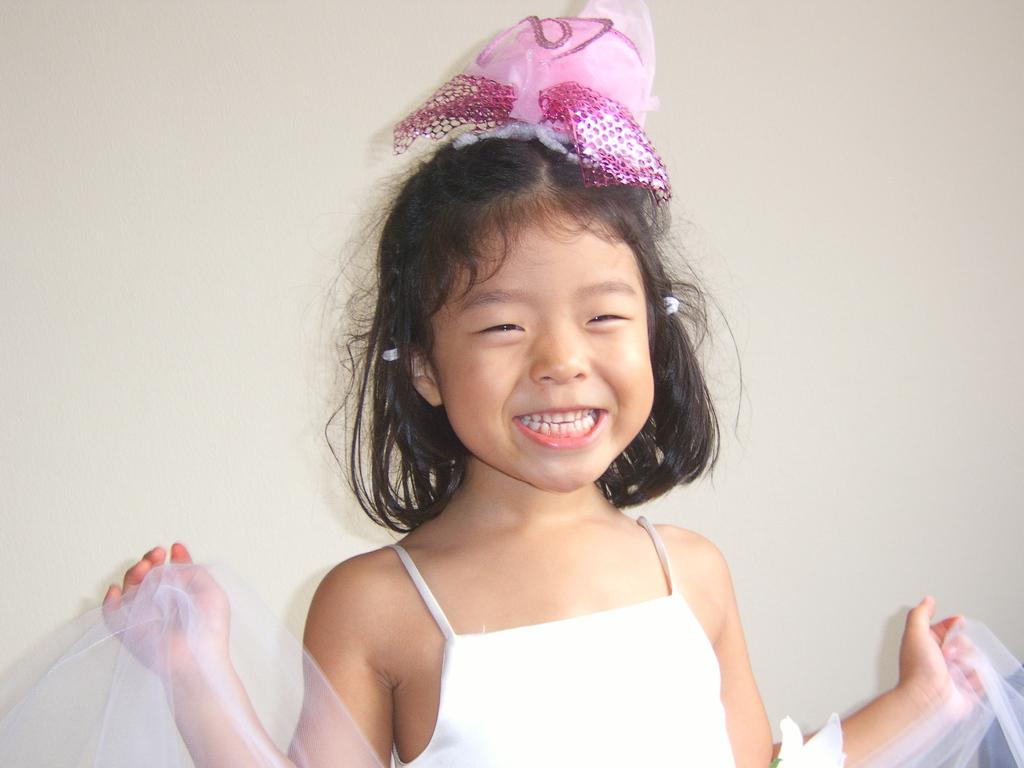Who is the main subject in the image? There is a girl in the center of the image. What can be seen behind the girl? There is a wall in the background of the image. What type of wool is being spun into a circle in the image? There is no wool or spinning activity present in the image. 